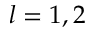<formula> <loc_0><loc_0><loc_500><loc_500>l = 1 , 2</formula> 